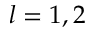<formula> <loc_0><loc_0><loc_500><loc_500>l = 1 , 2</formula> 